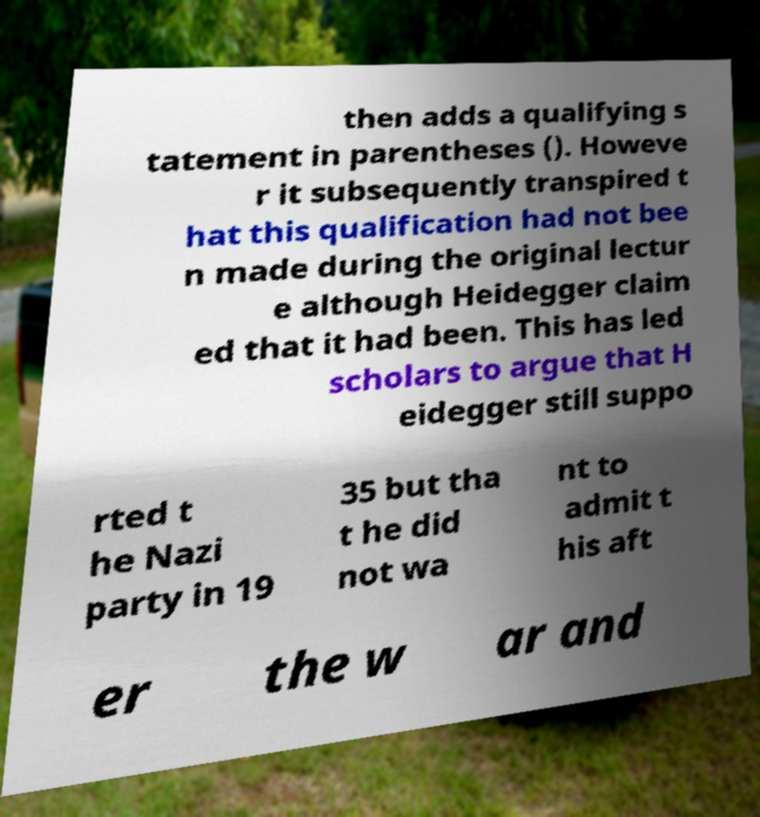For documentation purposes, I need the text within this image transcribed. Could you provide that? then adds a qualifying s tatement in parentheses (). Howeve r it subsequently transpired t hat this qualification had not bee n made during the original lectur e although Heidegger claim ed that it had been. This has led scholars to argue that H eidegger still suppo rted t he Nazi party in 19 35 but tha t he did not wa nt to admit t his aft er the w ar and 